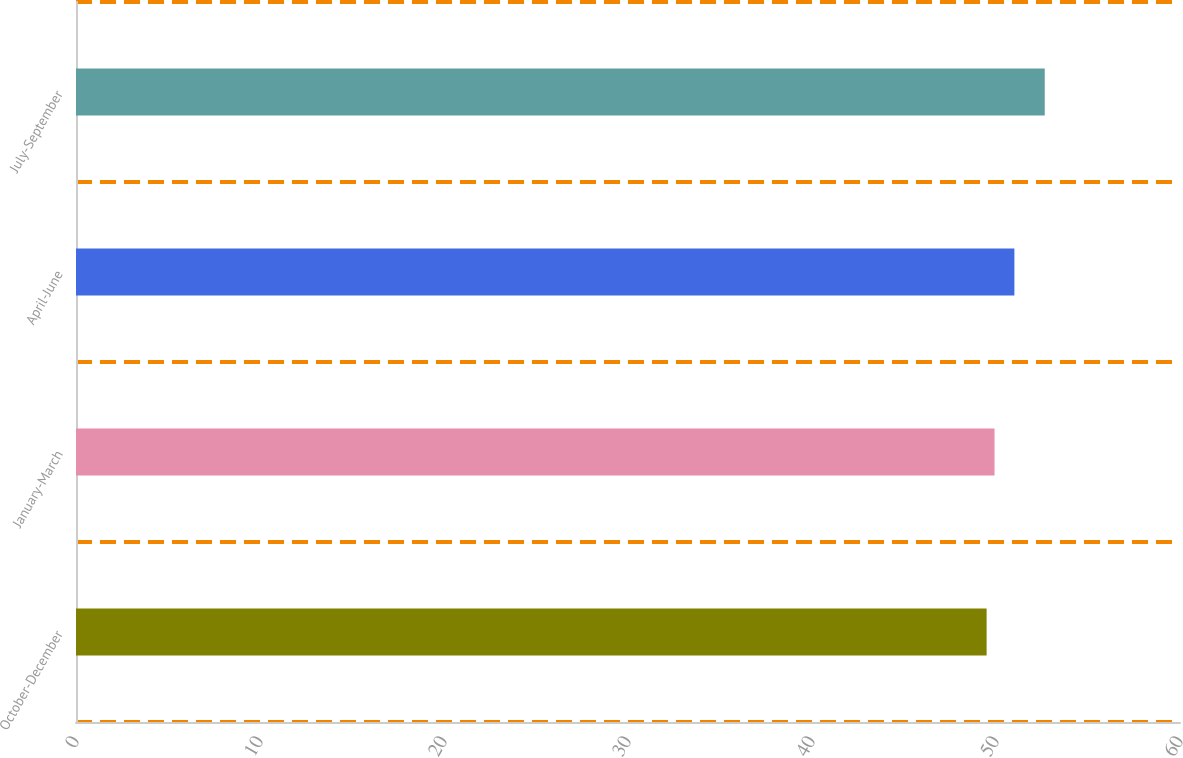Convert chart to OTSL. <chart><loc_0><loc_0><loc_500><loc_500><bar_chart><fcel>October-December<fcel>January-March<fcel>April-June<fcel>July-September<nl><fcel>49.49<fcel>49.92<fcel>51<fcel>52.65<nl></chart> 